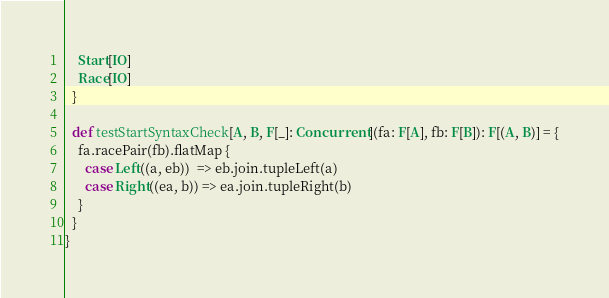Convert code to text. <code><loc_0><loc_0><loc_500><loc_500><_Scala_>    Start[IO]
    Race[IO]
  }

  def testStartSyntaxCheck[A, B, F[_]: Concurrent](fa: F[A], fb: F[B]): F[(A, B)] = {
    fa.racePair(fb).flatMap {
      case Left((a, eb))  => eb.join.tupleLeft(a)
      case Right((ea, b)) => ea.join.tupleRight(b)
    }
  }
}
</code> 